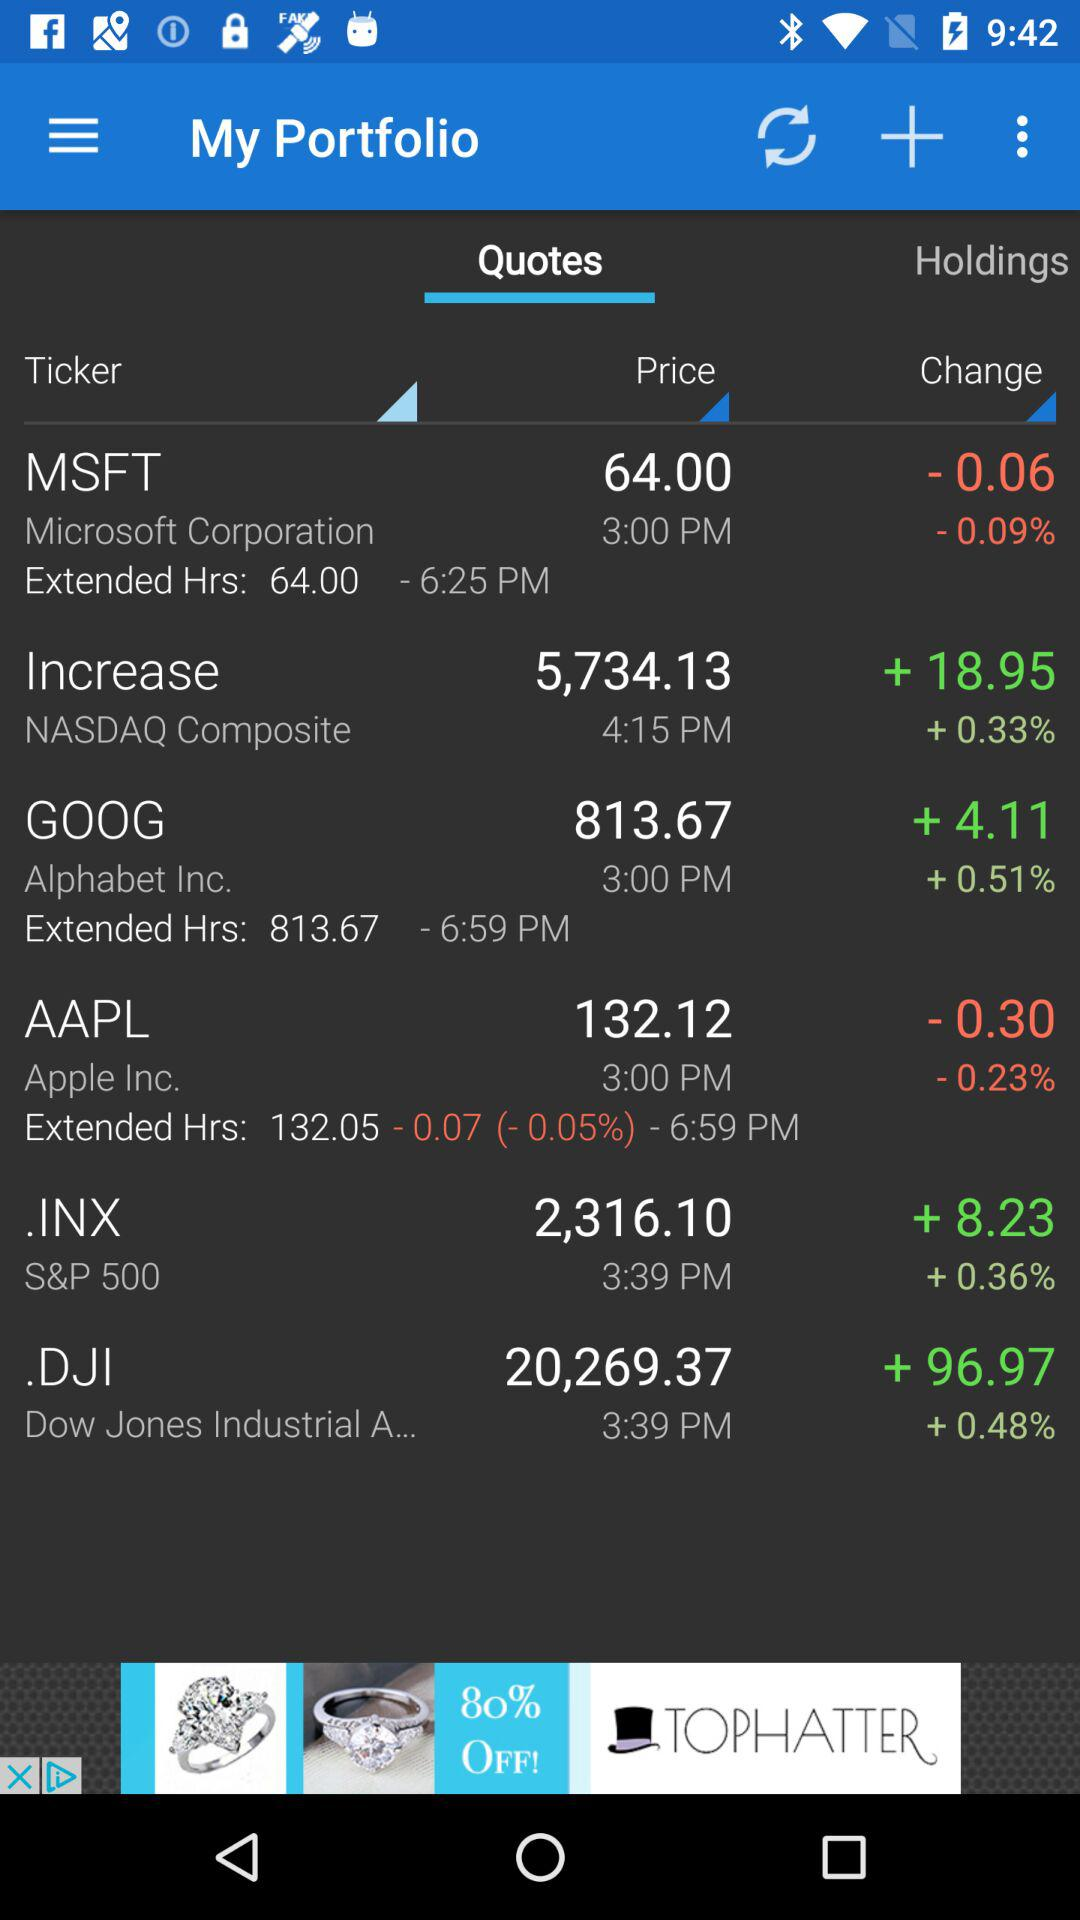Which option is selected? The selected options are "Quotes", "Ticker", "Price" and "Change". 